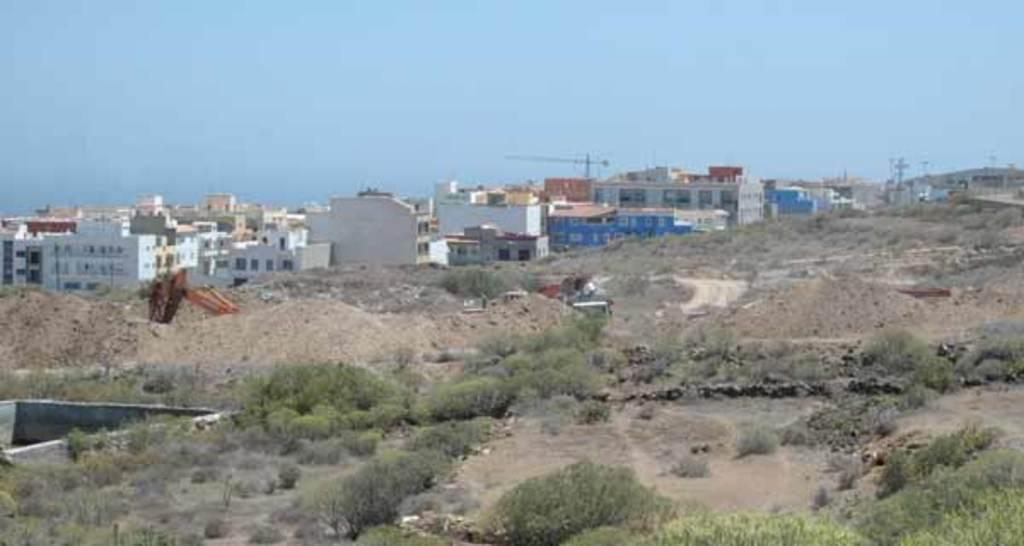What type of living organisms can be seen in the image? Plants can be seen in the image. What can be seen in the background of the image? There are buildings in the background of the image. What type of books can be seen in the image? There are no books present in the image; it features plants and buildings. What nerve is responsible for controlling the movement of the plants in the image? Plants do not have nerves, as they are not living organisms with a nervous system. 